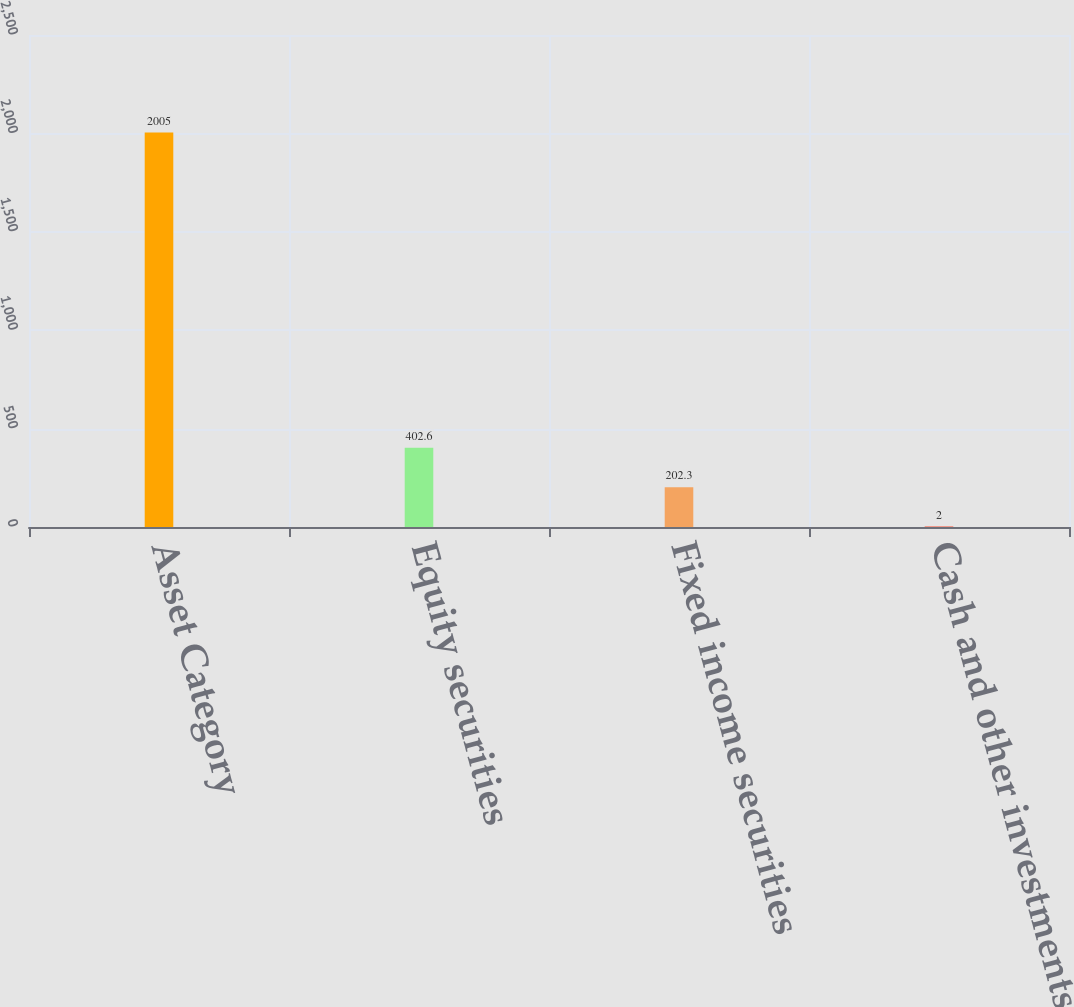Convert chart. <chart><loc_0><loc_0><loc_500><loc_500><bar_chart><fcel>Asset Category<fcel>Equity securities<fcel>Fixed income securities<fcel>Cash and other investments<nl><fcel>2005<fcel>402.6<fcel>202.3<fcel>2<nl></chart> 